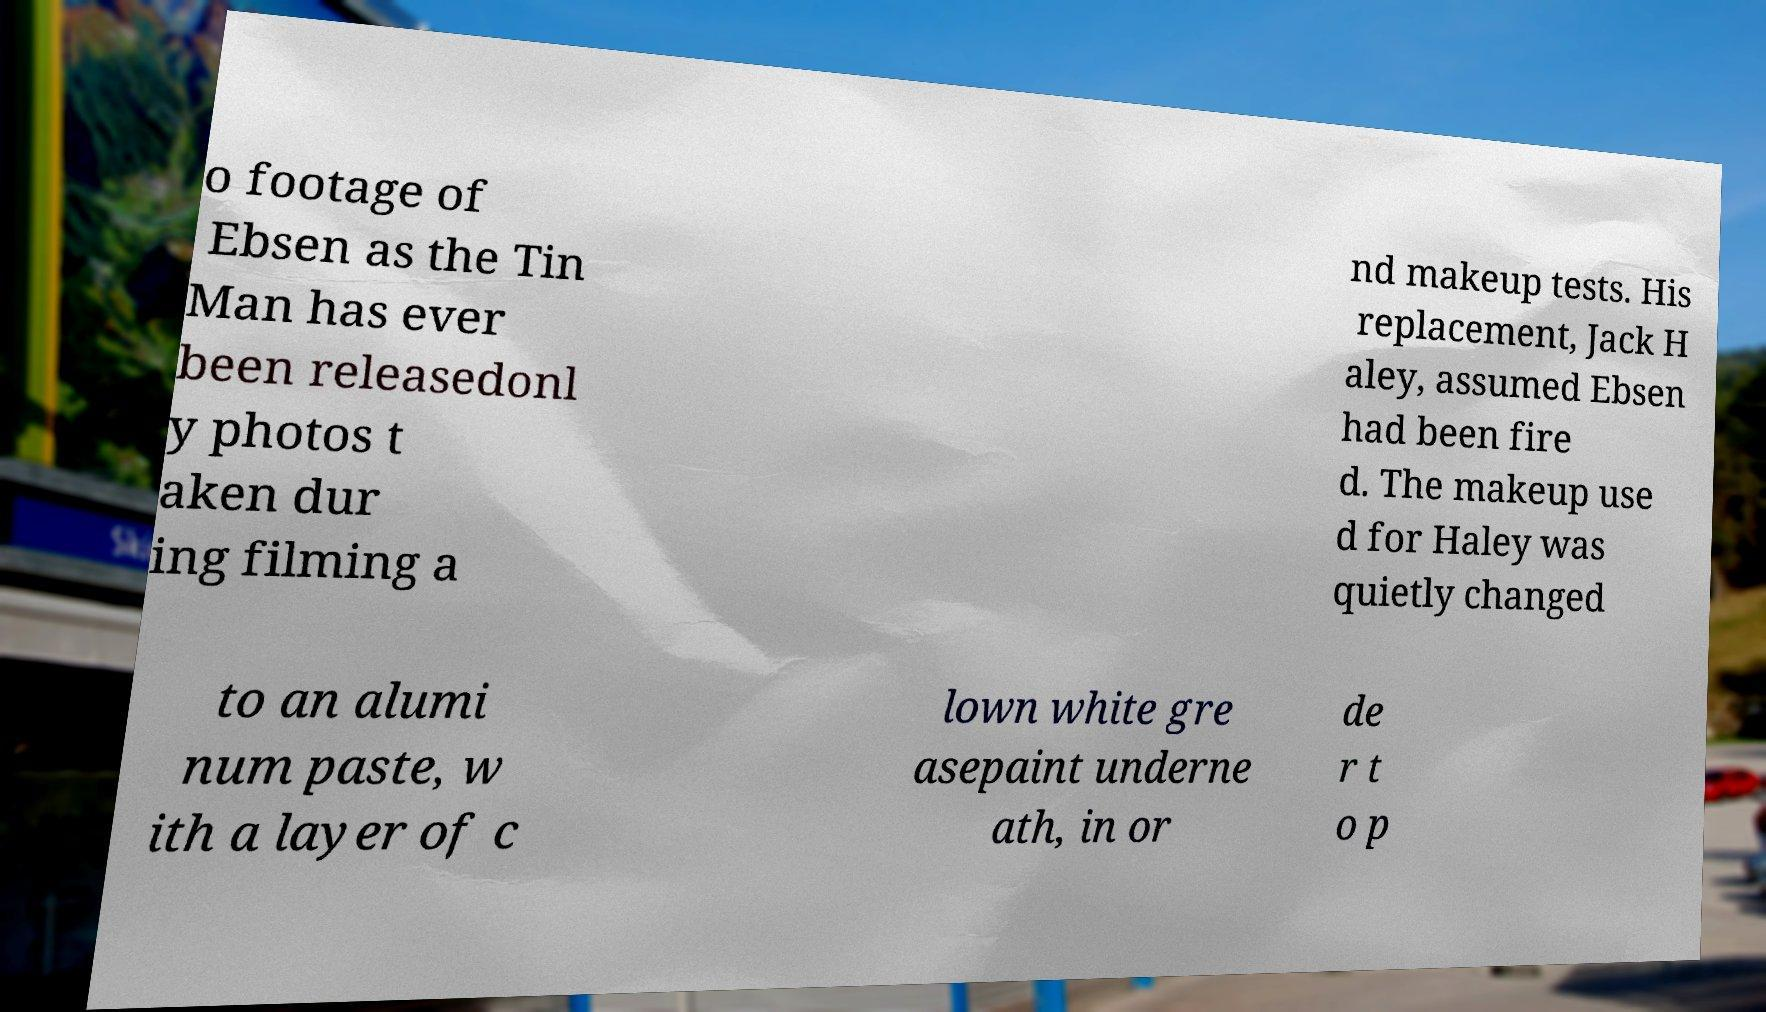Could you extract and type out the text from this image? o footage of Ebsen as the Tin Man has ever been releasedonl y photos t aken dur ing filming a nd makeup tests. His replacement, Jack H aley, assumed Ebsen had been fire d. The makeup use d for Haley was quietly changed to an alumi num paste, w ith a layer of c lown white gre asepaint underne ath, in or de r t o p 